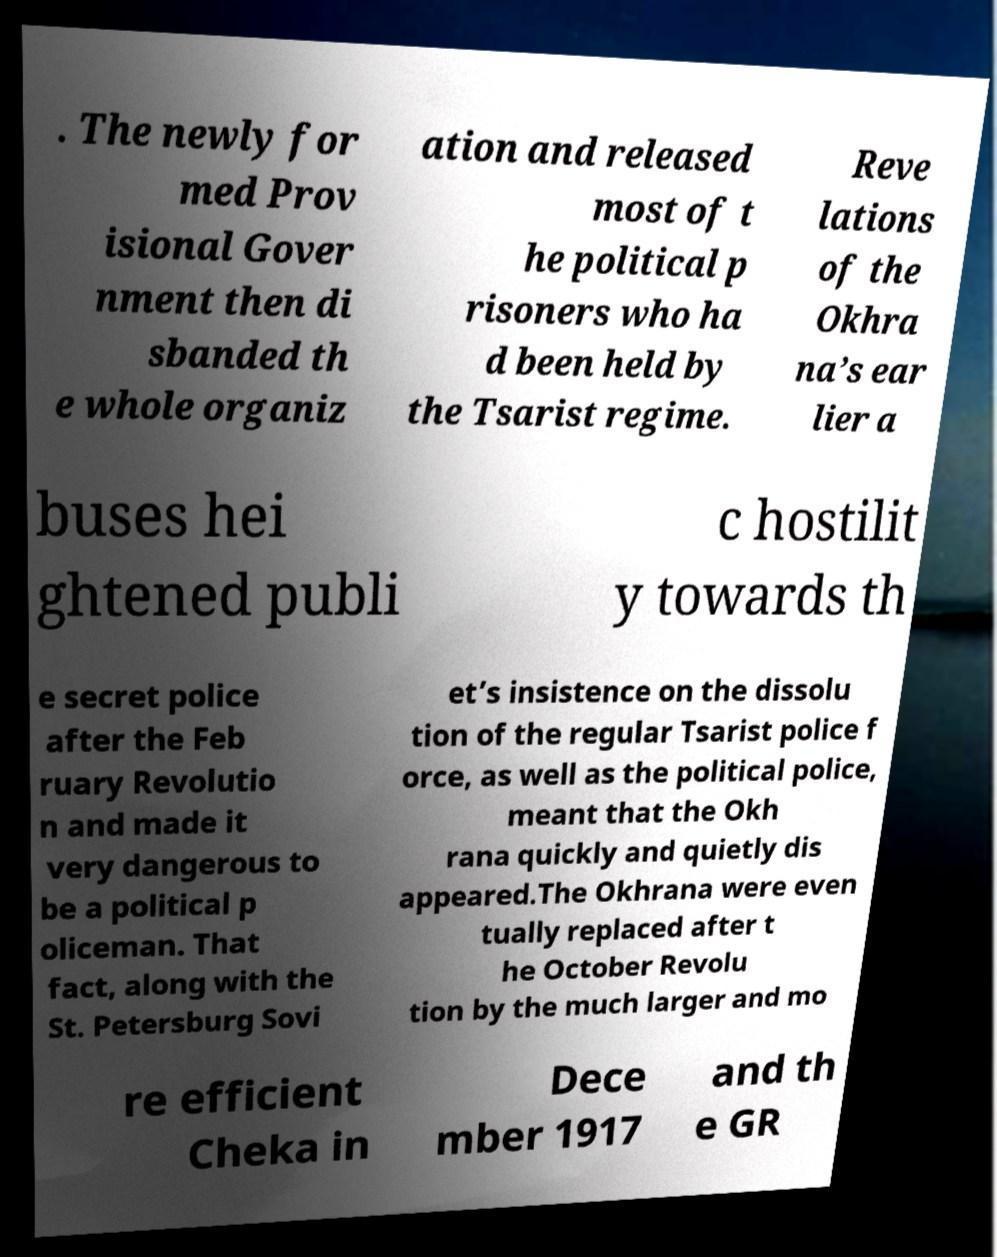Can you read and provide the text displayed in the image?This photo seems to have some interesting text. Can you extract and type it out for me? . The newly for med Prov isional Gover nment then di sbanded th e whole organiz ation and released most of t he political p risoners who ha d been held by the Tsarist regime. Reve lations of the Okhra na’s ear lier a buses hei ghtened publi c hostilit y towards th e secret police after the Feb ruary Revolutio n and made it very dangerous to be a political p oliceman. That fact, along with the St. Petersburg Sovi et’s insistence on the dissolu tion of the regular Tsarist police f orce, as well as the political police, meant that the Okh rana quickly and quietly dis appeared.The Okhrana were even tually replaced after t he October Revolu tion by the much larger and mo re efficient Cheka in Dece mber 1917 and th e GR 